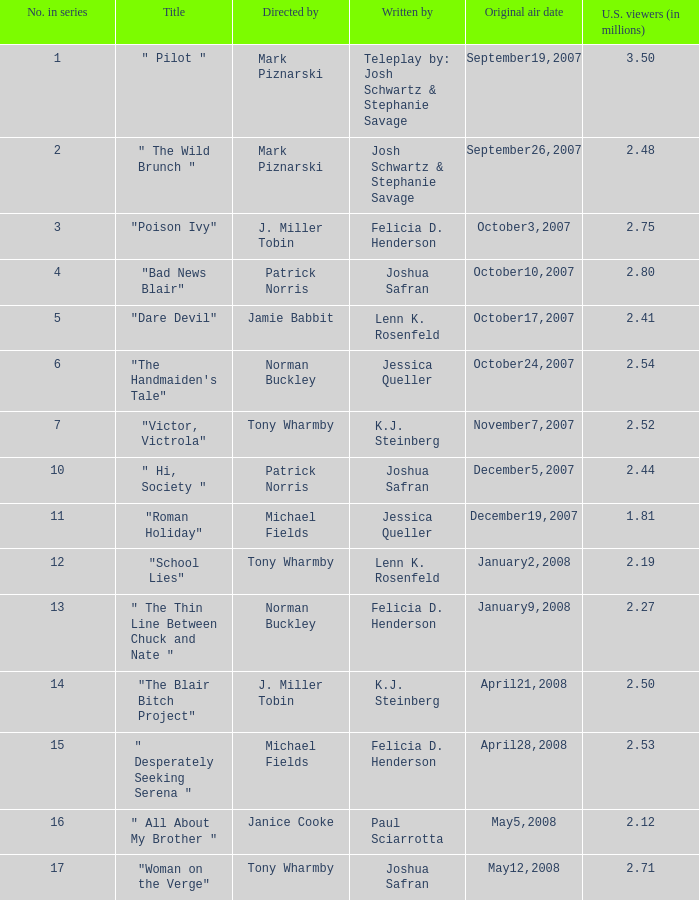80 as u.s. spectators (in millions)? 1.0. 